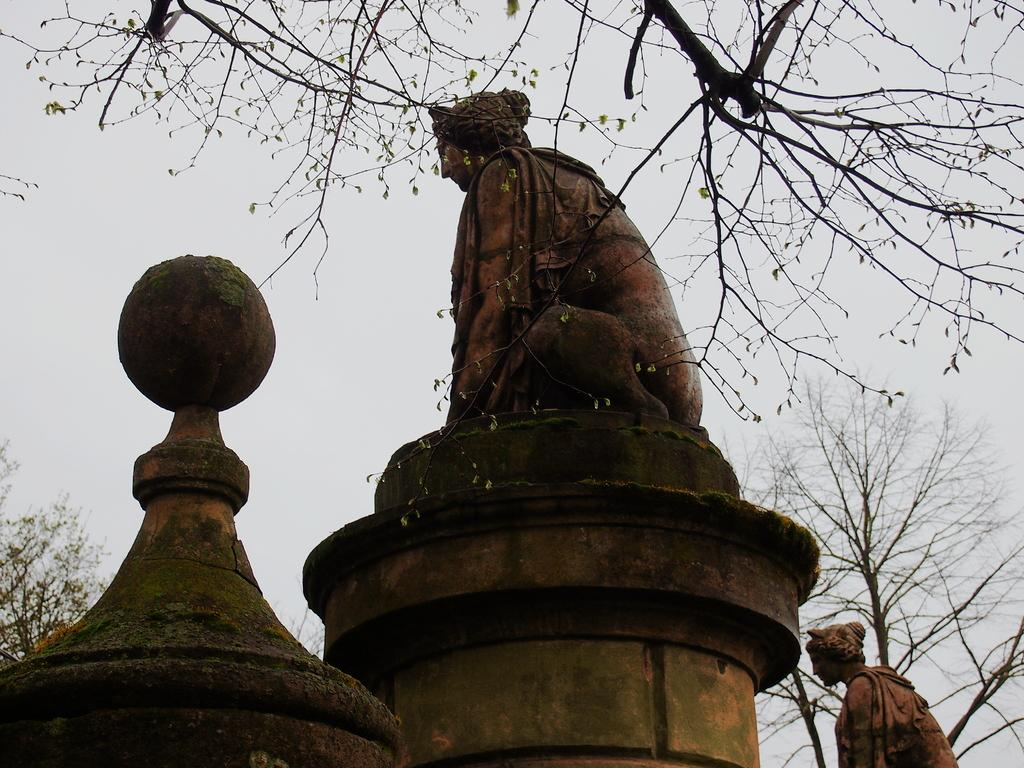What type of art is present in the image? There are sculptures in the image. What type of vegetation can be seen in the front of the image? There are trees in the front of the image. What is visible in the background of the image? The sky is visible in the background of the image. How many dinosaurs can be seen interacting with the sculptures in the image? There are no dinosaurs present in the image; it features sculptures and trees. What type of arm is visible on the sculptures in the image? The sculptures in the image do not have arms, as they are not human or animal figures. 